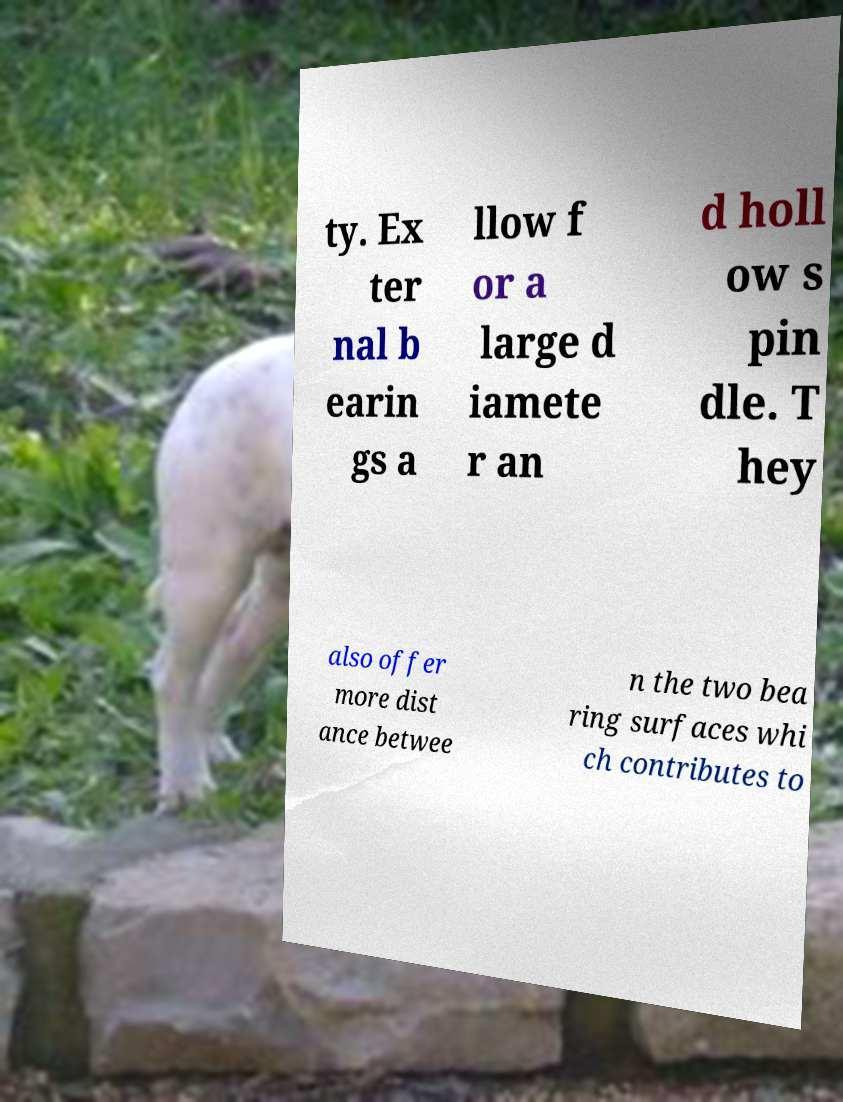I need the written content from this picture converted into text. Can you do that? ty. Ex ter nal b earin gs a llow f or a large d iamete r an d holl ow s pin dle. T hey also offer more dist ance betwee n the two bea ring surfaces whi ch contributes to 